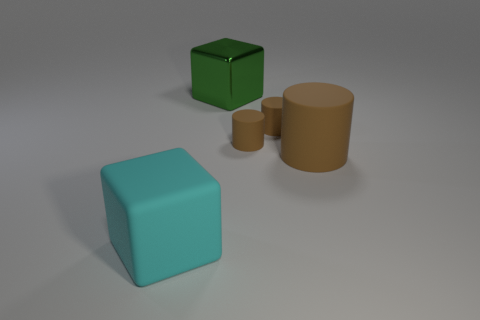Subtract all brown cylinders. How many were subtracted if there are1brown cylinders left? 2 Subtract 1 cylinders. How many cylinders are left? 2 Add 2 cylinders. How many objects exist? 7 Subtract all blocks. How many objects are left? 3 Add 3 cylinders. How many cylinders are left? 6 Add 2 tiny brown matte cylinders. How many tiny brown matte cylinders exist? 4 Subtract 0 green cylinders. How many objects are left? 5 Subtract all small cylinders. Subtract all matte blocks. How many objects are left? 2 